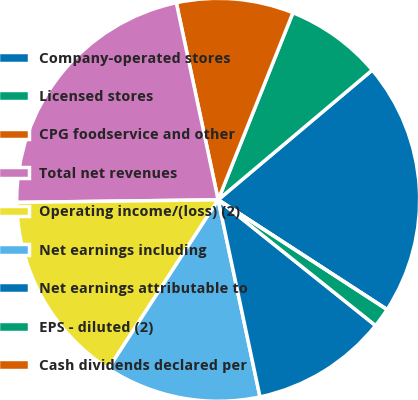<chart> <loc_0><loc_0><loc_500><loc_500><pie_chart><fcel>Company-operated stores<fcel>Licensed stores<fcel>CPG foodservice and other<fcel>Total net revenues<fcel>Operating income/(loss) (2)<fcel>Net earnings including<fcel>Net earnings attributable to<fcel>EPS - diluted (2)<fcel>Cash dividends declared per<nl><fcel>20.31%<fcel>7.81%<fcel>9.38%<fcel>21.87%<fcel>15.62%<fcel>12.5%<fcel>10.94%<fcel>1.56%<fcel>0.0%<nl></chart> 